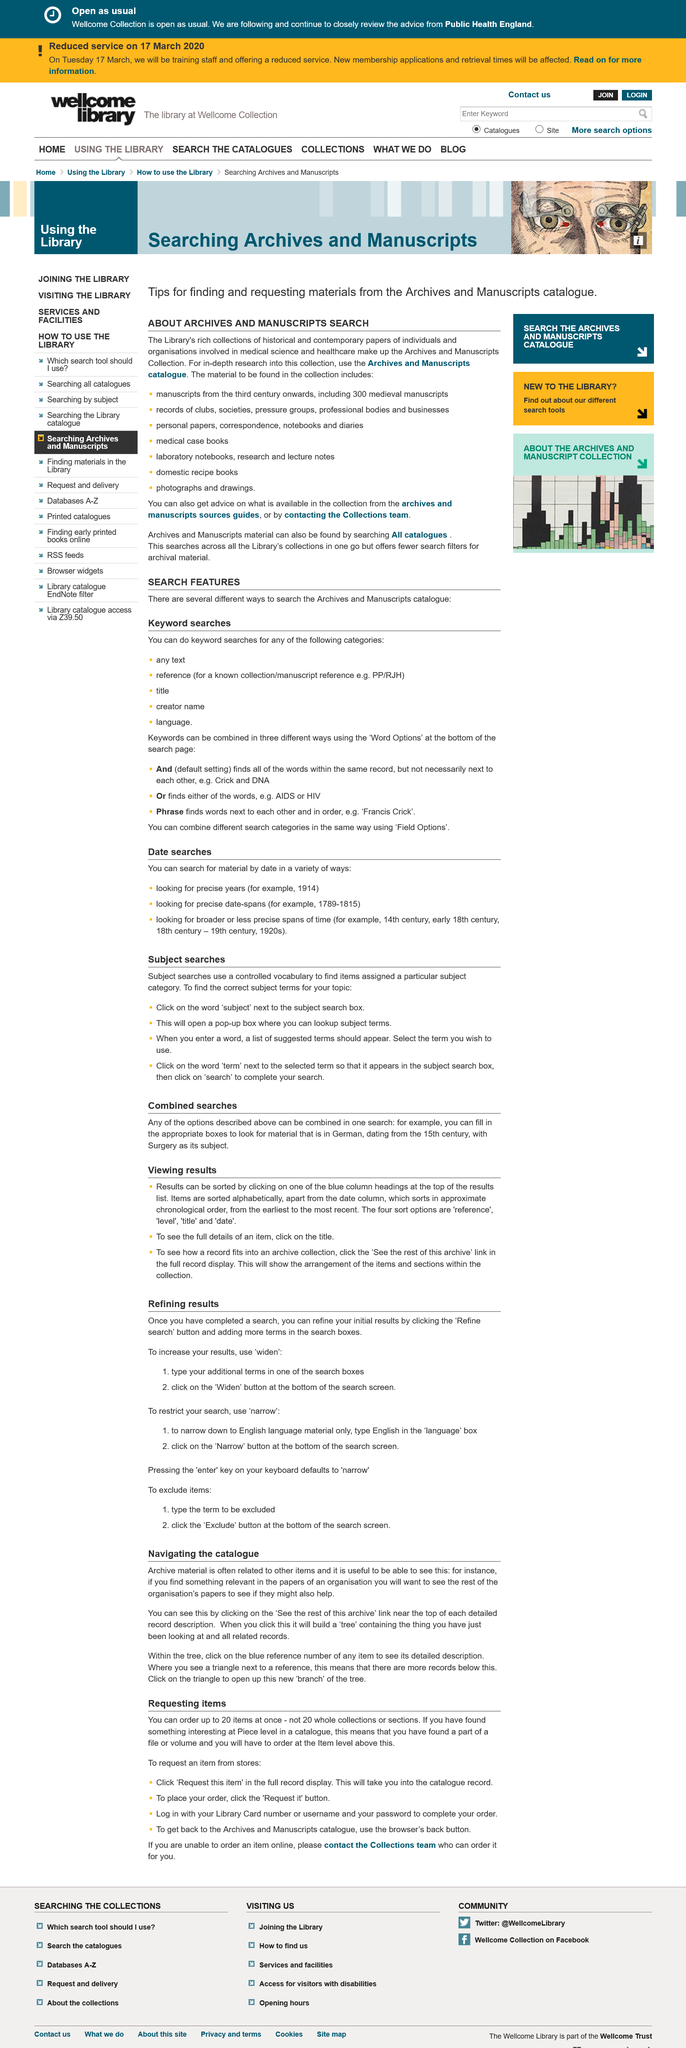Draw attention to some important aspects in this diagram. Four sort options are reference, level, title, and date. Sorting the results is possible by clicking on one of the blue column headings at the top of the results list. Yes, it is possible to combine the options described above in a single search. 